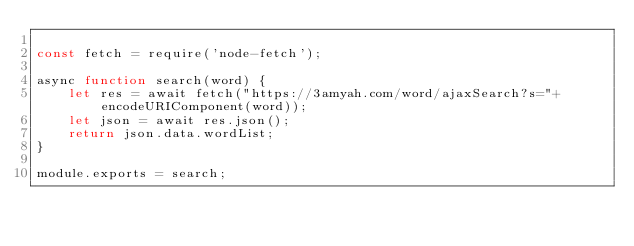Convert code to text. <code><loc_0><loc_0><loc_500><loc_500><_JavaScript_>
const fetch = require('node-fetch');

async function search(word) {
    let res = await fetch("https://3amyah.com/word/ajaxSearch?s="+ encodeURIComponent(word));
    let json = await res.json();
    return json.data.wordList;
}

module.exports = search;</code> 